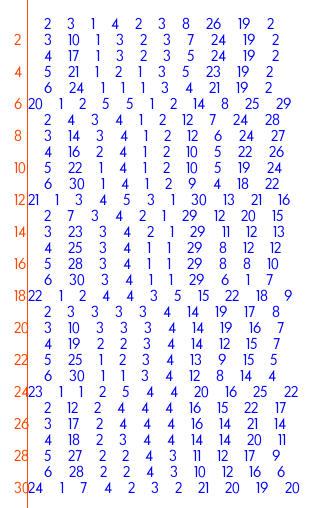Convert code to text. <code><loc_0><loc_0><loc_500><loc_500><_ObjectiveC_>	2	3	1	4	2	3	8	26	19	2	
	3	10	1	3	2	3	7	24	19	2	
	4	17	1	3	2	3	5	24	19	2	
	5	21	1	2	1	3	5	23	19	2	
	6	24	1	1	1	3	4	21	19	2	
20	1	2	5	5	1	2	14	8	25	29	
	2	4	3	4	1	2	12	7	24	28	
	3	14	3	4	1	2	12	6	24	27	
	4	16	2	4	1	2	10	5	22	26	
	5	22	1	4	1	2	10	5	19	24	
	6	30	1	4	1	2	9	4	18	22	
21	1	3	4	5	3	1	30	13	21	16	
	2	7	3	4	2	1	29	12	20	15	
	3	23	3	4	2	1	29	11	12	13	
	4	25	3	4	1	1	29	8	12	12	
	5	28	3	4	1	1	29	8	8	10	
	6	30	3	4	1	1	29	6	1	7	
22	1	2	4	4	3	5	15	22	18	9	
	2	3	3	3	3	4	14	19	17	8	
	3	10	3	3	3	4	14	19	16	7	
	4	19	2	2	3	4	14	12	15	7	
	5	25	1	2	3	4	13	9	15	5	
	6	30	1	1	3	4	12	8	14	4	
23	1	1	2	5	4	4	20	16	25	22	
	2	12	2	4	4	4	16	15	22	17	
	3	17	2	4	4	4	16	14	21	14	
	4	18	2	3	4	4	14	14	20	11	
	5	27	2	2	4	3	11	12	17	9	
	6	28	2	2	4	3	10	12	16	6	
24	1	7	4	2	3	2	21	20	19	20	</code> 